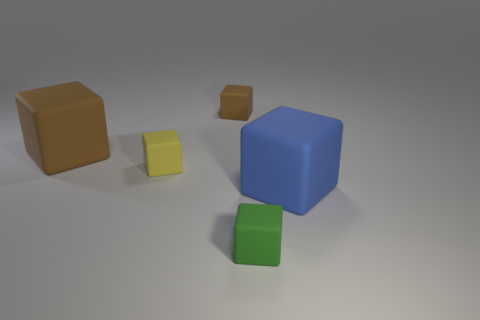There is a brown thing that is the same size as the yellow block; what shape is it?
Offer a terse response. Cube. Is the number of large blue rubber things greater than the number of small objects?
Your answer should be very brief. No. There is a brown cube behind the large brown rubber object; are there any large matte objects to the left of it?
Offer a terse response. Yes. What is the color of the other large thing that is the same shape as the large blue object?
Make the answer very short. Brown. There is a big object that is the same material as the big brown cube; what color is it?
Make the answer very short. Blue. Are there any big matte things left of the big rubber block right of the object left of the small yellow cube?
Keep it short and to the point. Yes. Is the number of big brown matte blocks on the right side of the large brown cube less than the number of tiny yellow cubes that are in front of the tiny brown cube?
Provide a succinct answer. Yes. What number of blue things are the same material as the yellow thing?
Provide a short and direct response. 1. Is the size of the green rubber object the same as the matte object that is on the right side of the small green rubber cube?
Your answer should be compact. No. What size is the brown object that is to the right of the large thing that is to the left of the brown cube that is on the right side of the large brown thing?
Your response must be concise. Small. 